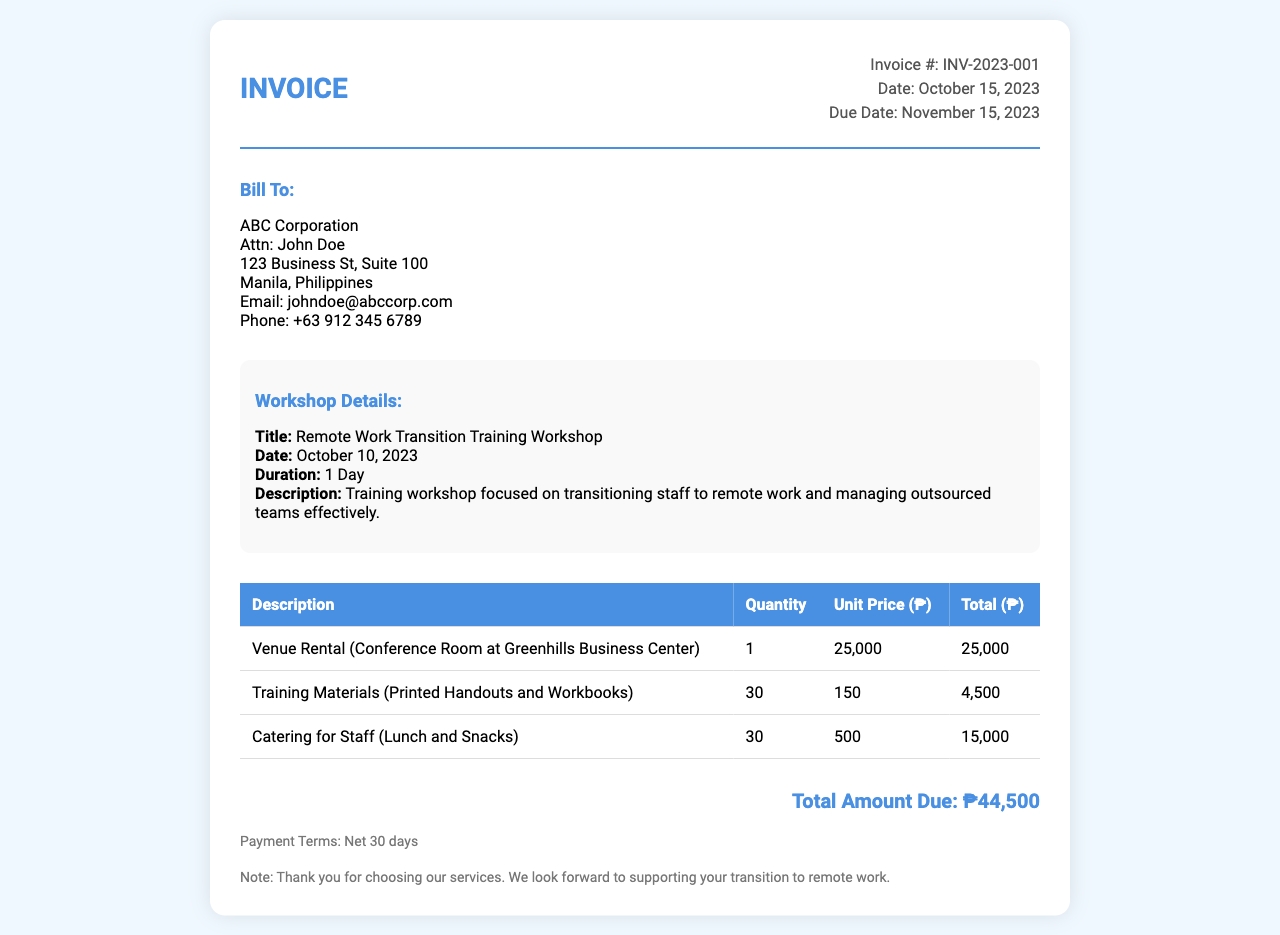what is the invoice number? The invoice number is specified in the header section of the document.
Answer: INV-2023-001 what is the total amount due? The total amount due is located at the bottom of the document, summing all expenses.
Answer: ₱44,500 who is the contact person for billing? The contact person is mentioned in the billing info section.
Answer: John Doe what is the date of the workshop? The workshop date is detailed in the workshop details section.
Answer: October 10, 2023 how many training materials were provided? The quantity of training materials is noted in the invoice table.
Answer: 30 what is the unit price for catering? The unit price for catering is listed in the invoice table for catering services.
Answer: 500 what are the payment terms? The payment terms are provided towards the end of the document.
Answer: Net 30 days what was the venue used for the workshop? The venue is identified in the description of the venue rental in the table.
Answer: Greenhills Business Center what type of catering was included? The description of catering provided can be found in the table section of the invoice.
Answer: Lunch and Snacks 